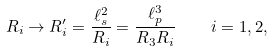<formula> <loc_0><loc_0><loc_500><loc_500>R _ { i } \rightarrow R _ { i } ^ { \prime } = \frac { \ell _ { s } ^ { 2 } } { R _ { i } } = \frac { \ell _ { p } ^ { 3 } } { R _ { 3 } R _ { i } } \quad i = 1 , 2 ,</formula> 